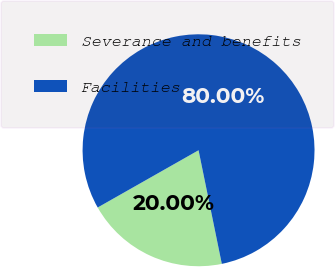<chart> <loc_0><loc_0><loc_500><loc_500><pie_chart><fcel>Severance and benefits<fcel>Facilities<nl><fcel>20.0%<fcel>80.0%<nl></chart> 